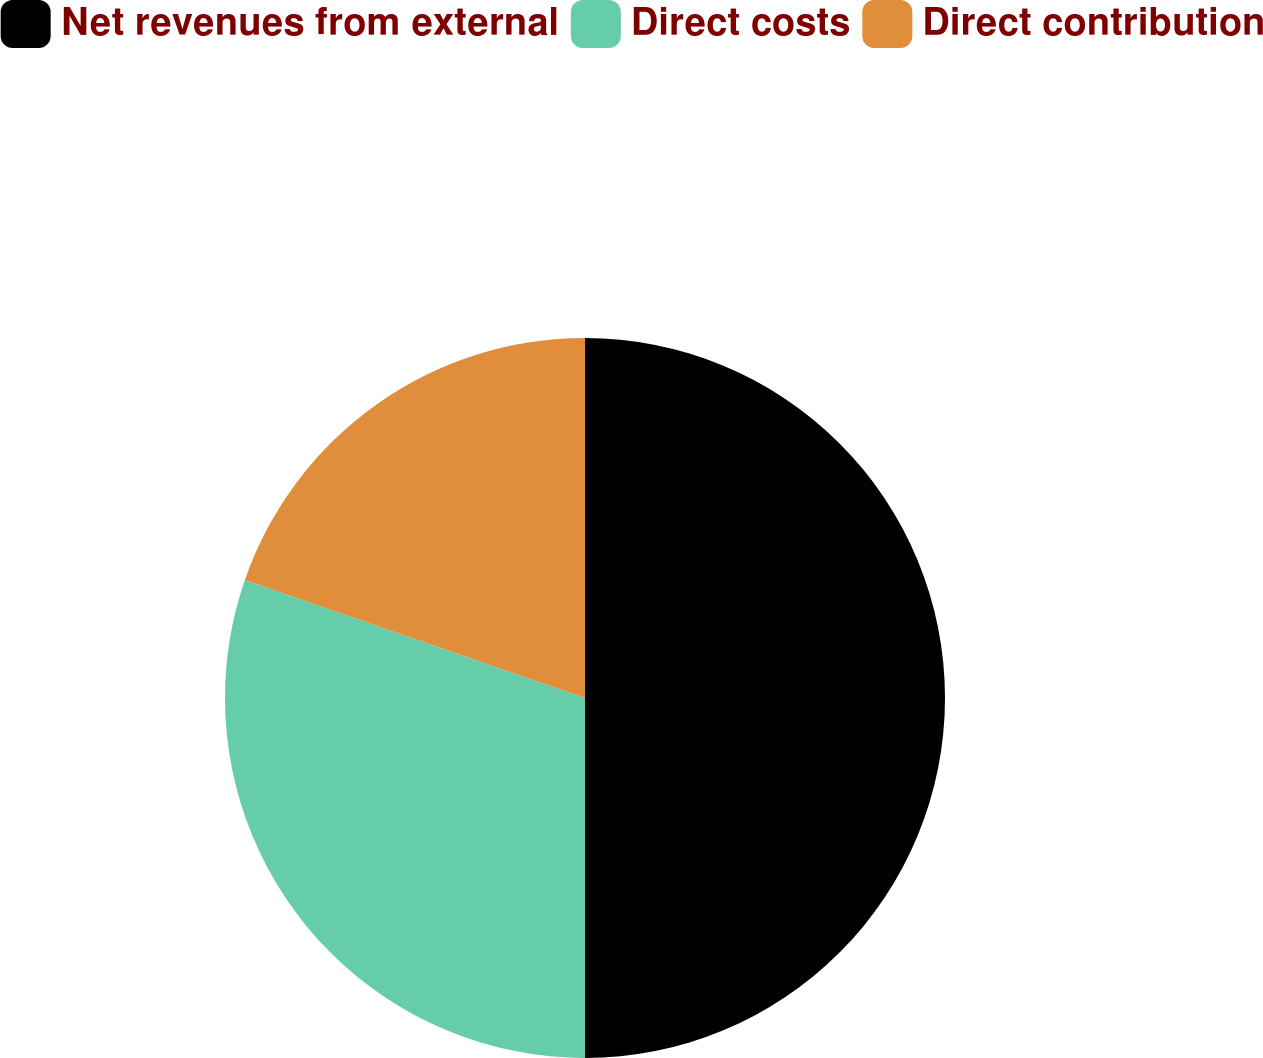<chart> <loc_0><loc_0><loc_500><loc_500><pie_chart><fcel>Net revenues from external<fcel>Direct costs<fcel>Direct contribution<nl><fcel>50.0%<fcel>30.31%<fcel>19.69%<nl></chart> 